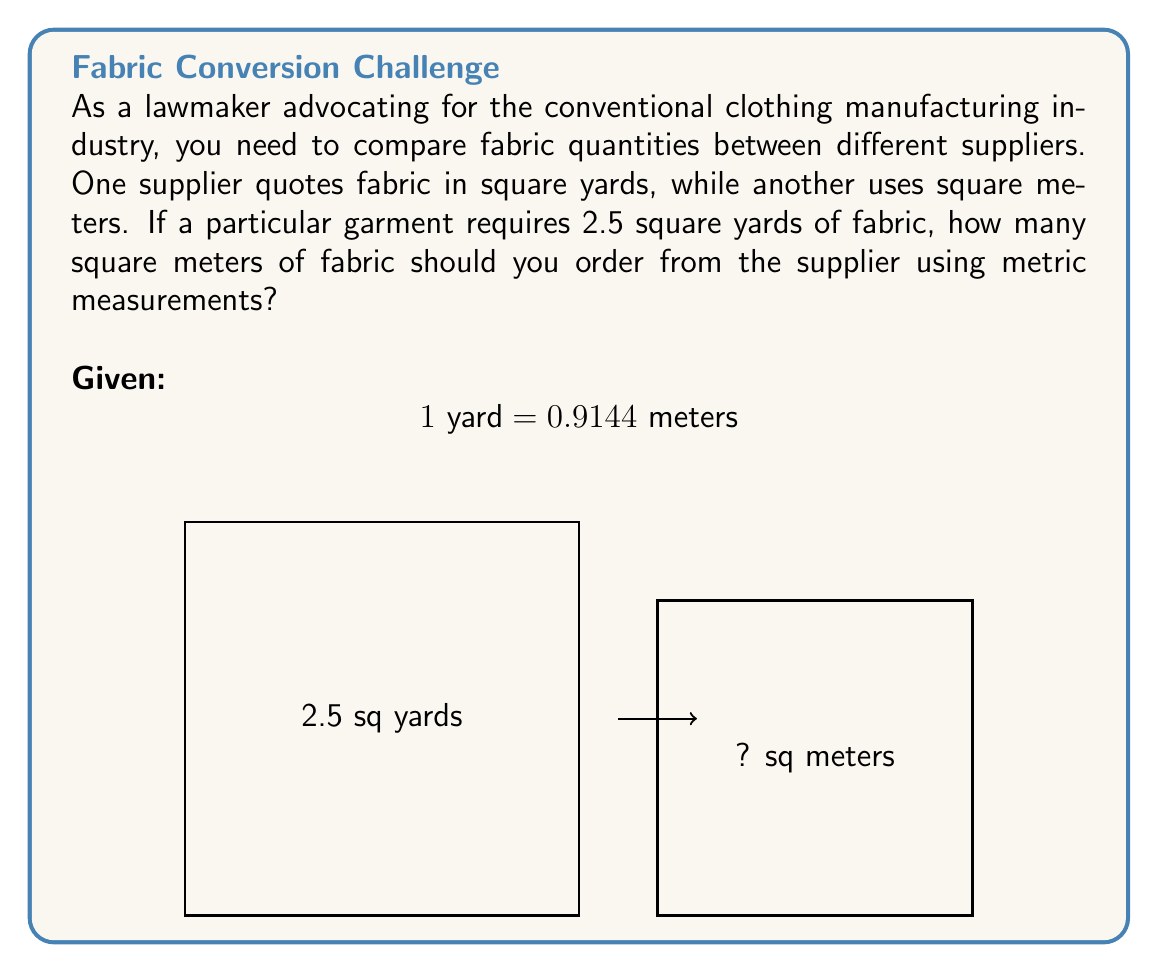Give your solution to this math problem. To convert from square yards to square meters, we need to follow these steps:

1) First, let's establish the conversion factor:
   1 yard = 0.9144 meters
   
2) To convert square yards to square meters, we need to square this conversion factor:
   $(0.9144 \text{ m})^2 = 0.8361 \text{ m}^2$

3) So, 1 square yard = 0.8361 square meters

4) Now, we can set up the conversion equation:
   $2.5 \text{ yd}^2 \times \frac{0.8361 \text{ m}^2}{1 \text{ yd}^2} = x \text{ m}^2$

5) Solving for x:
   $x = 2.5 \times 0.8361 = 2.09025 \text{ m}^2$

6) Rounding to two decimal places:
   $x \approx 2.09 \text{ m}^2$

Therefore, you should order 2.09 square meters of fabric from the supplier using metric measurements.
Answer: $2.09 \text{ m}^2$ 